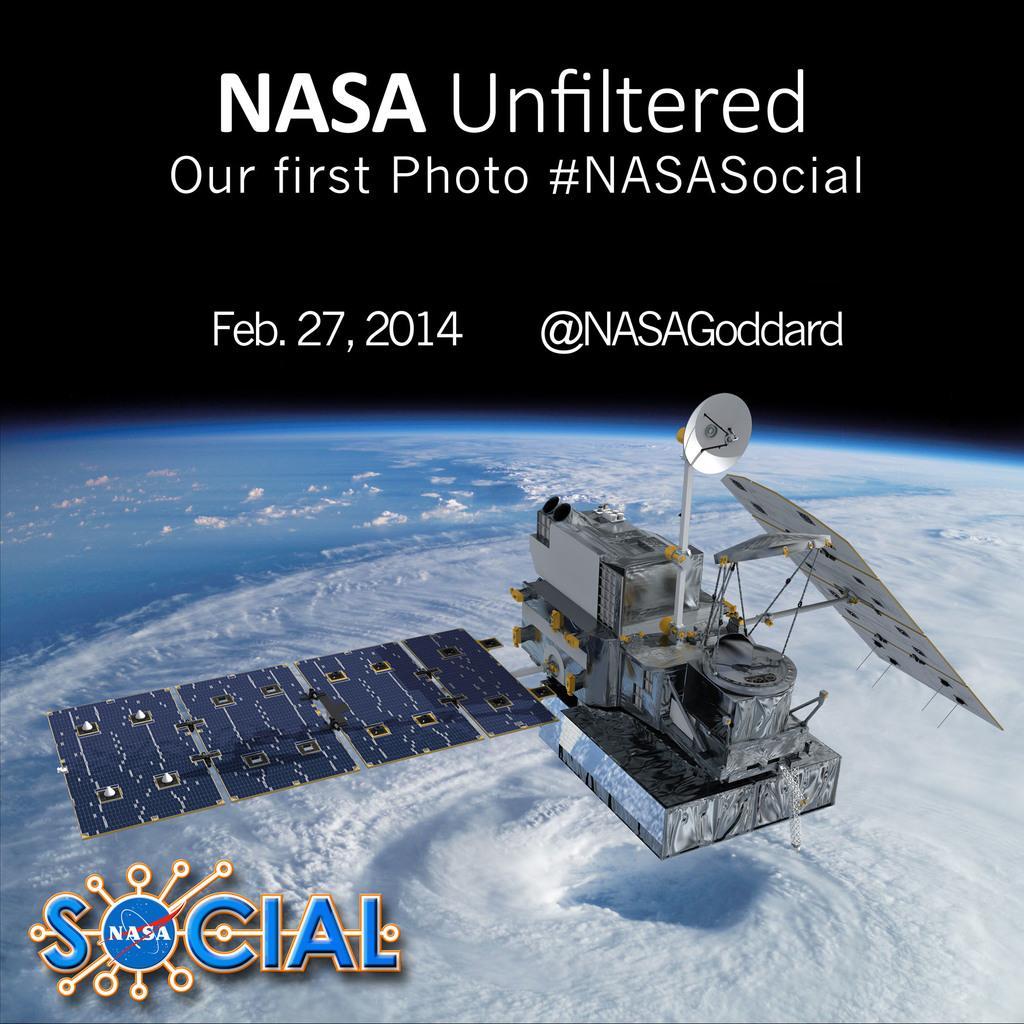Please provide a concise description of this image. There is a satellite above the earth and there is text at the top and bottom side. 